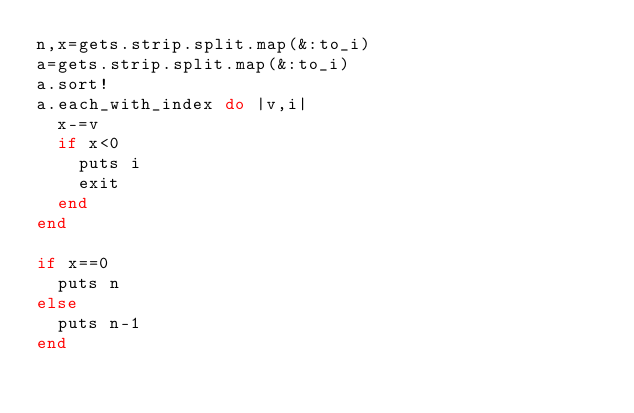<code> <loc_0><loc_0><loc_500><loc_500><_Ruby_>n,x=gets.strip.split.map(&:to_i)
a=gets.strip.split.map(&:to_i)
a.sort!
a.each_with_index do |v,i|
  x-=v
  if x<0
    puts i
    exit
  end
end

if x==0
  puts n
else
  puts n-1
end</code> 